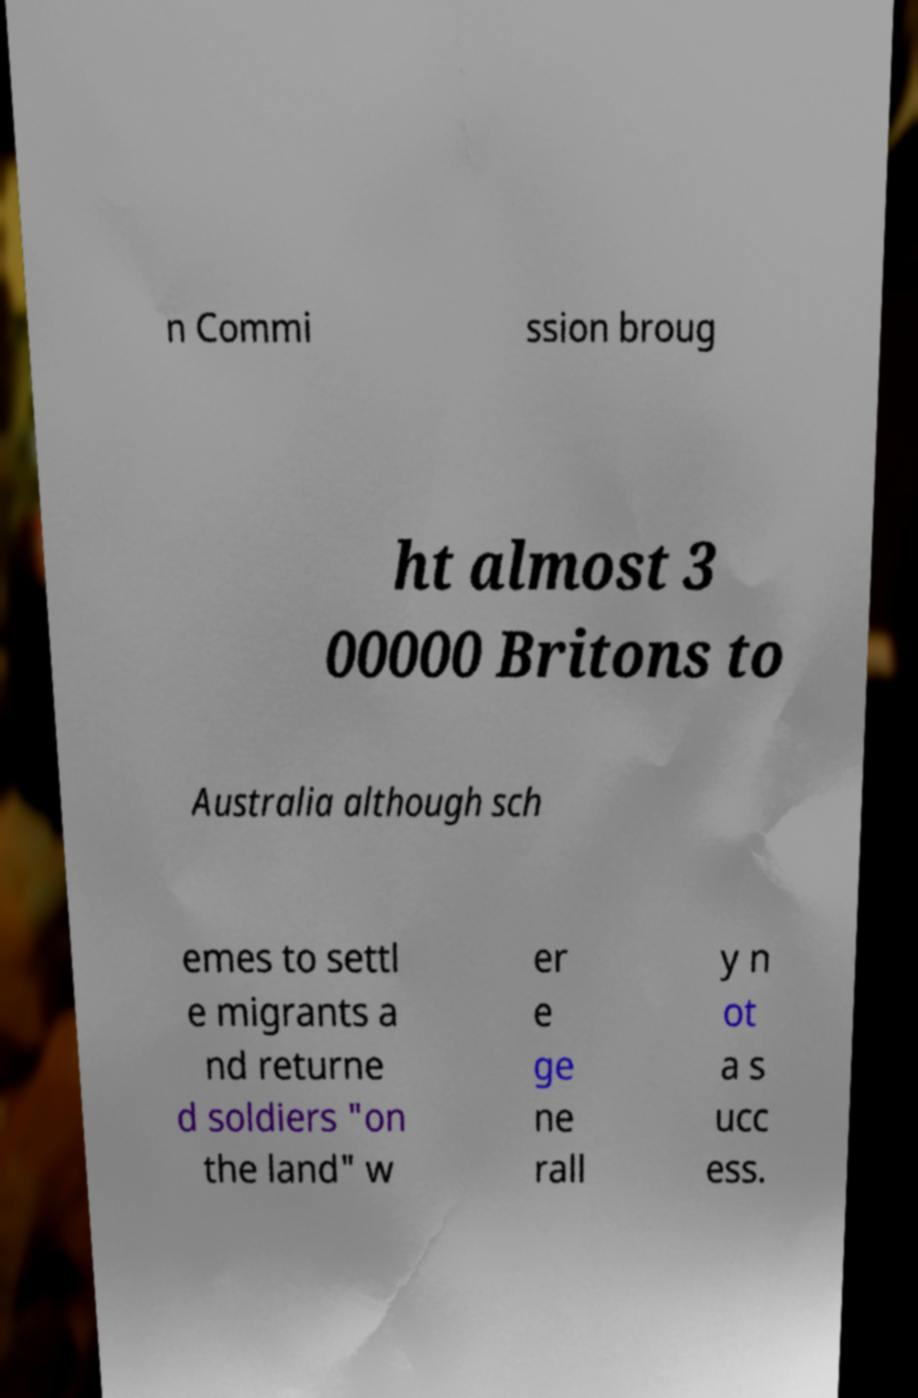There's text embedded in this image that I need extracted. Can you transcribe it verbatim? n Commi ssion broug ht almost 3 00000 Britons to Australia although sch emes to settl e migrants a nd returne d soldiers "on the land" w er e ge ne rall y n ot a s ucc ess. 